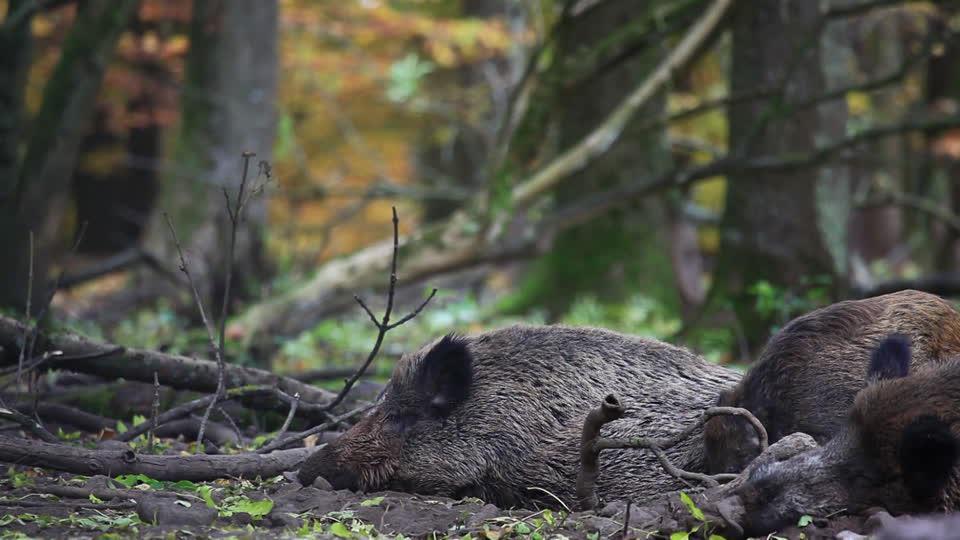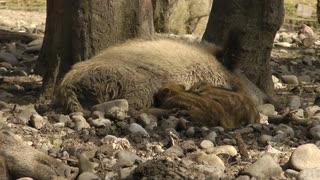The first image is the image on the left, the second image is the image on the right. Evaluate the accuracy of this statement regarding the images: "The left image contains exactly one boar.". Is it true? Answer yes or no. No. The first image is the image on the left, the second image is the image on the right. Assess this claim about the two images: "An image shows at least two baby piglets with distinctive striped fur lying in front of an older wild pig that is lying on its side.". Correct or not? Answer yes or no. Yes. 